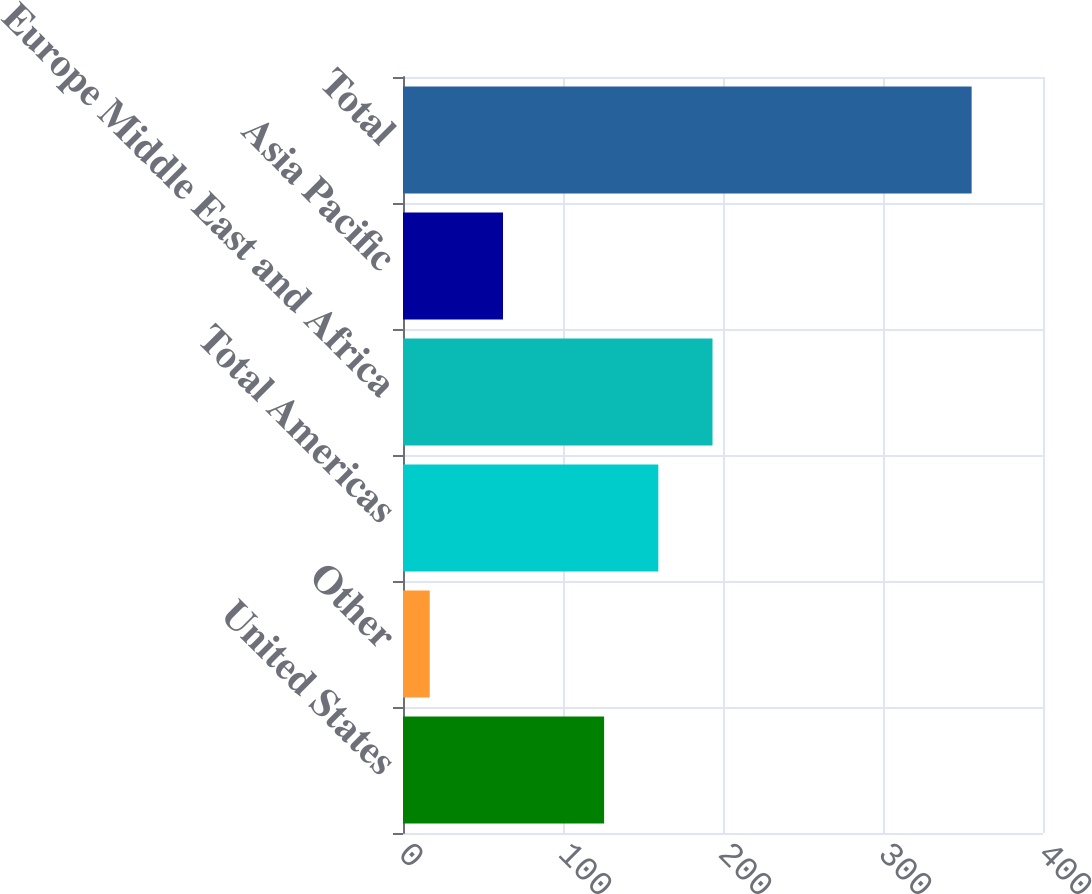Convert chart to OTSL. <chart><loc_0><loc_0><loc_500><loc_500><bar_chart><fcel>United States<fcel>Other<fcel>Total Americas<fcel>Europe Middle East and Africa<fcel>Asia Pacific<fcel>Total<nl><fcel>125.7<fcel>16.7<fcel>159.57<fcel>193.44<fcel>62.5<fcel>355.4<nl></chart> 